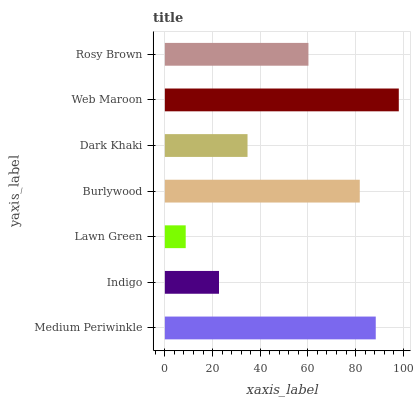Is Lawn Green the minimum?
Answer yes or no. Yes. Is Web Maroon the maximum?
Answer yes or no. Yes. Is Indigo the minimum?
Answer yes or no. No. Is Indigo the maximum?
Answer yes or no. No. Is Medium Periwinkle greater than Indigo?
Answer yes or no. Yes. Is Indigo less than Medium Periwinkle?
Answer yes or no. Yes. Is Indigo greater than Medium Periwinkle?
Answer yes or no. No. Is Medium Periwinkle less than Indigo?
Answer yes or no. No. Is Rosy Brown the high median?
Answer yes or no. Yes. Is Rosy Brown the low median?
Answer yes or no. Yes. Is Burlywood the high median?
Answer yes or no. No. Is Dark Khaki the low median?
Answer yes or no. No. 